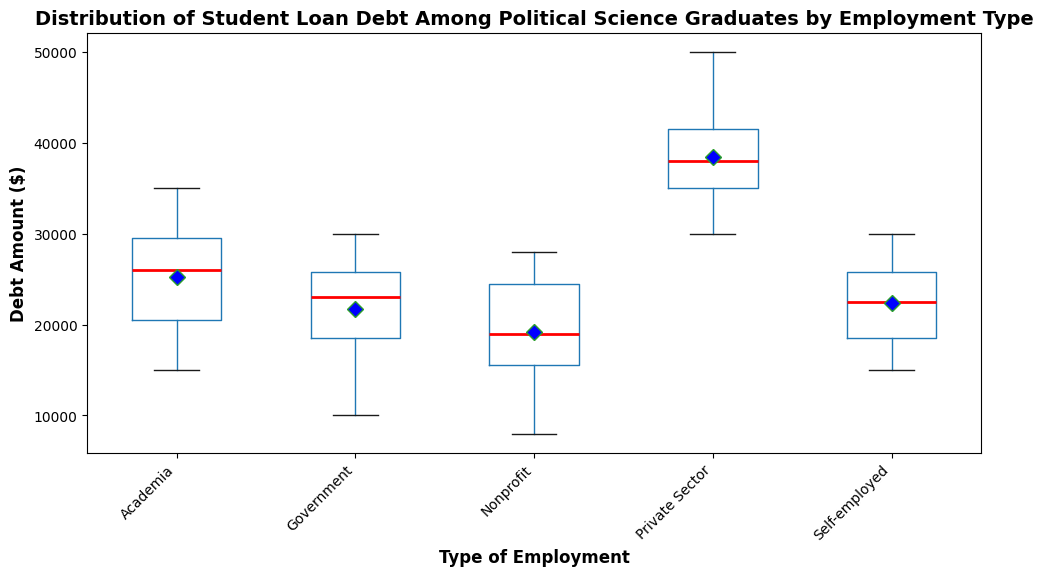What is the median debt amount for graduates employed in the Private Sector? The red line inside the box for the Private Sector indicates the median debt amount. By observing the position of this line within the Private Sector category, we determine the median debt amount.
Answer: 39,000 Which employment type has the highest mean debt amount? The blue diamond shapes on the plot indicate the mean debt amount. By comparing these shapes across all employment types, we can find the highest mean debt amount.
Answer: Private Sector By roughly how much does the third quartile for Government employment exceed the median debt for Academia? First, identify the third quartile for Government employment, which is the top of the box. Then, identify the median for Academia, which is the red line within the Academia box. Subtract the Academia median from the Government third quartile.
Answer: Approximately 8,000 Which employment type has the most consistent (less spread-out) distribution of debt amounts? Examine the width of the boxes for each employment type. The smallest box width represents the most consistent distribution.
Answer: Nonprofit What is the range of debt amounts for self-employed graduates? The range can be determined by subtracting the minimum debt amount (bottom whisker) from the maximum debt amount (top whisker) for the Self-employed category.
Answer: 15,000 Which employment type has the largest interquartile range (IQR)? The IQR is determined by the height of the box (distance between the first and third quartiles). Compare the height of the boxes across all employment types.
Answer: Private Sector Is the median debt amount for nonprofits more, less, or equal to the mean debt amount for academia? Look at the red line in the Nonprofit box for its median and the blue diamond in the Academia box for its mean. Compare these two visual indicators.
Answer: Less Which employment type has the smallest median debt amount and what is its value? Identify the position of the red line within each box. The smallest median will be the lowest positioned red line.
Answer: Government, 22,000 Are there any outliers in Academia's debt distribution according to the plot? Outliers are indicated by green dots outside the whiskers of the box. Check the Academia category for any such dots.
Answer: No For which employment type is the maximum debt amount closest to the minimum debt amount for Government employment? Identify the top whisker for each employment type and compare it to the bottom whisker of the Government category. The type with values closest to Government's minimum is desired.
Answer: Self-employed 